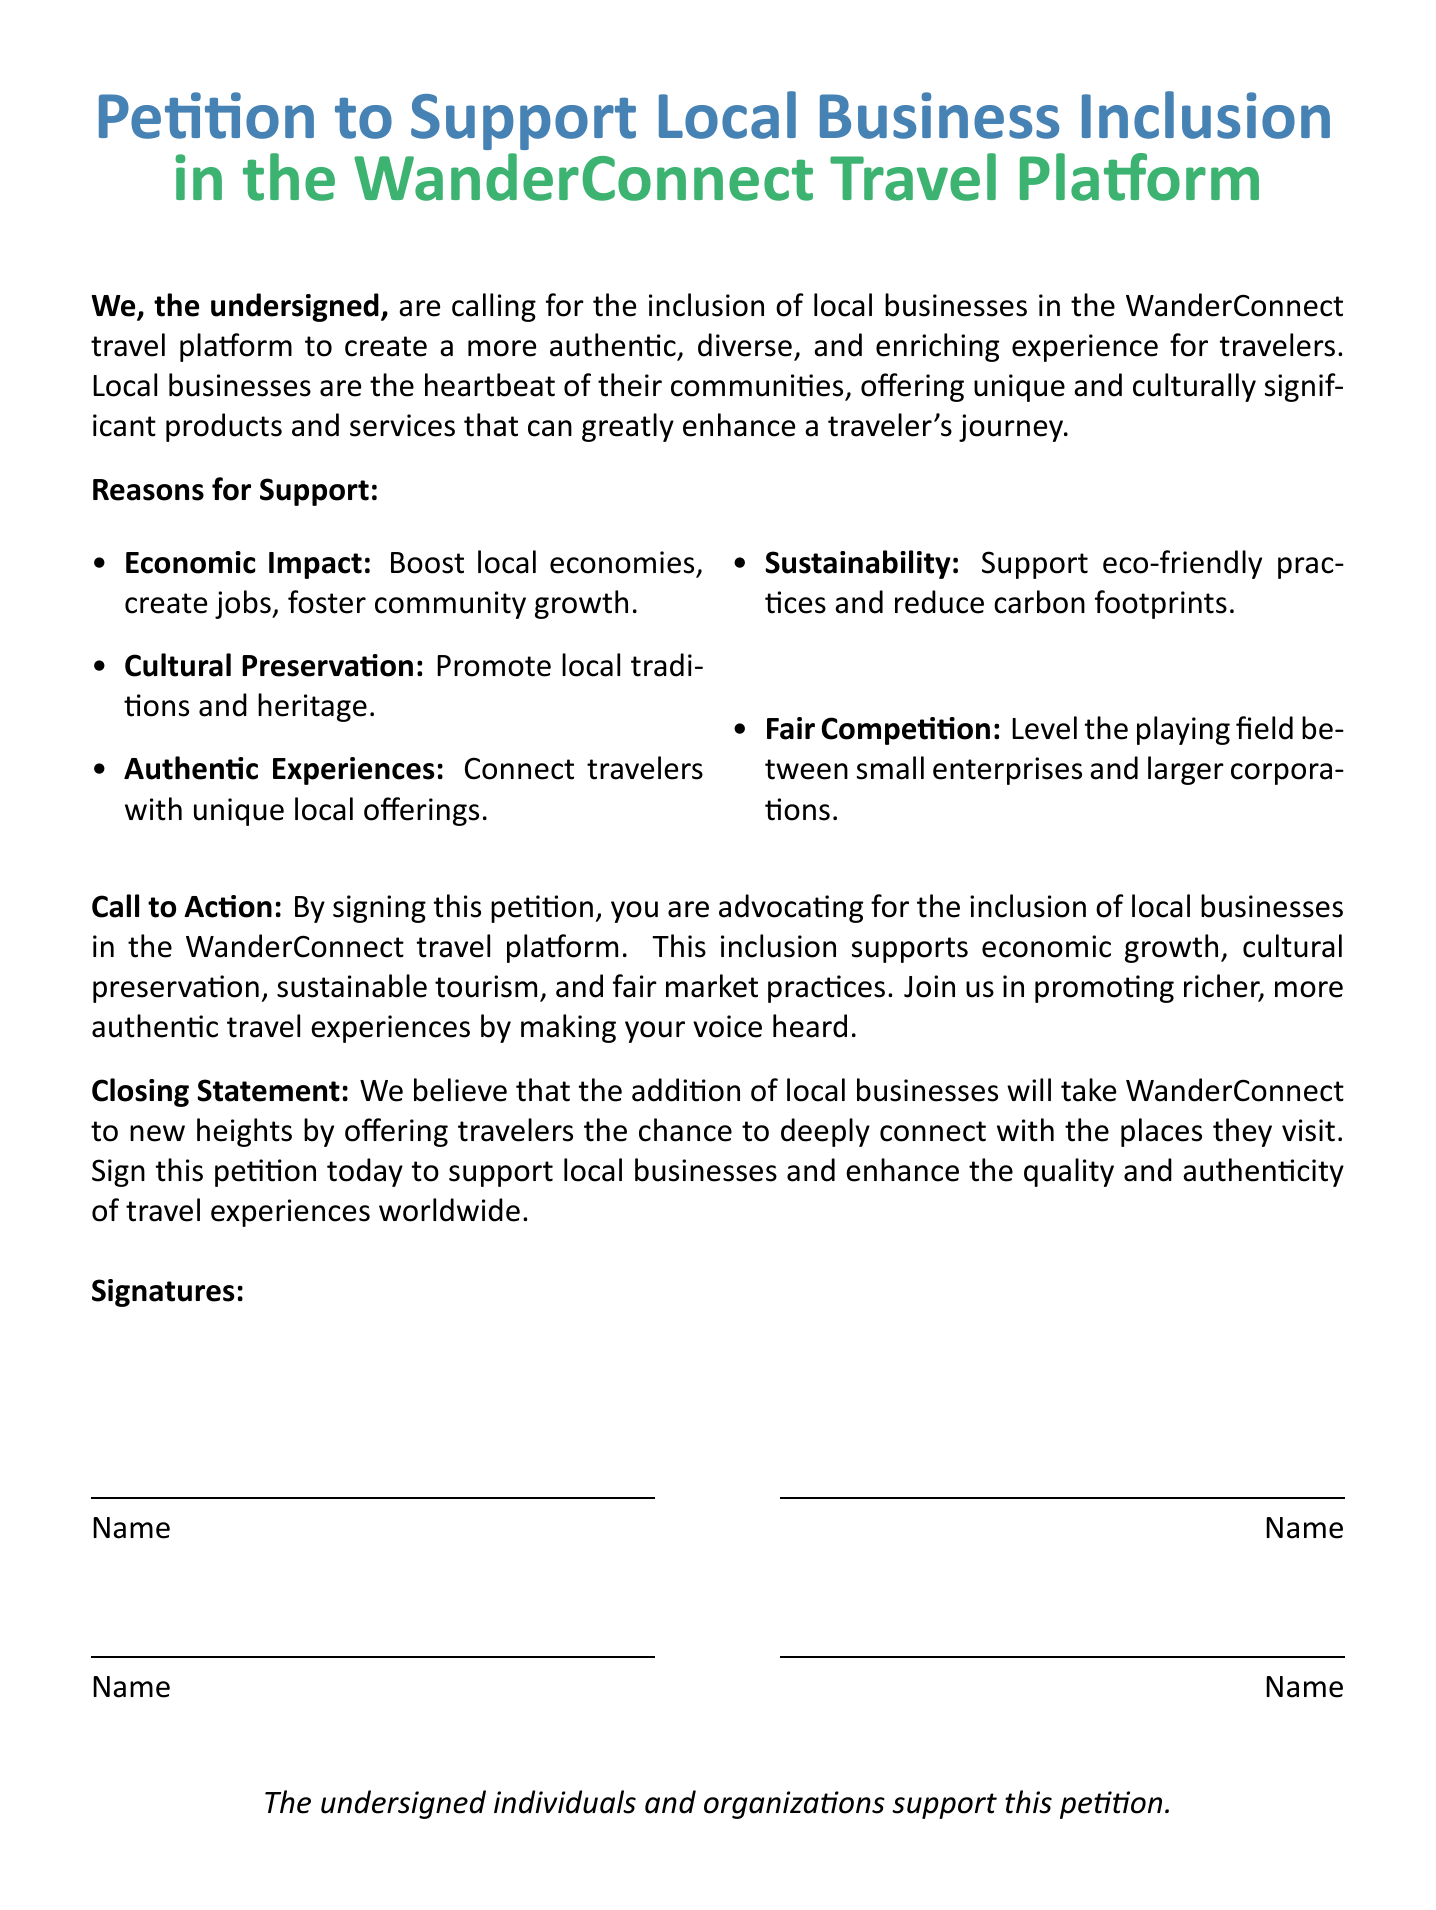what is the title of the petition? The title of the petition is specified at the top of the document.
Answer: Petition to Support Local Business Inclusion what is the primary platform mentioned in the petition? The primary platform mentioned in the petition is the WanderConnect travel platform.
Answer: WanderConnect how many reasons for support are listed in the document? The document states several reasons for support in a list, which can be counted.
Answer: Five what is one of the economic impacts mentioned? The document lists several impacts, including economic ones.
Answer: Boost local economies what is the call to action in the petition? The call to action is described towards the end of the document urging individuals to take a specific step.
Answer: Advocating for the inclusion of local businesses what will the addition of local businesses enhance according to the petition? The document mentions what the inclusion of local businesses will improve in relation to the travel experience.
Answer: Quality and authenticity how are signatures represented in the petition? The document outlines how individuals sign to show their support.
Answer: Name who is the target group for this petition? The petition is aimed at a specific group who would benefit from its implementation.
Answer: Travelers what color represents ‘experience’ in the document? The document specifies colors associated with the themes in the title.
Answer: experiencegreen how many lines are available for signatures in the document? The document provides a visual format for signatures that can be counted.
Answer: Four 